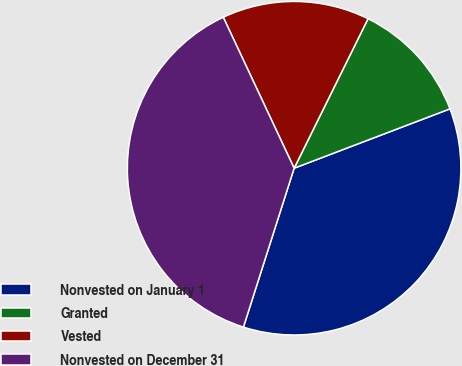Convert chart. <chart><loc_0><loc_0><loc_500><loc_500><pie_chart><fcel>Nonvested on January 1<fcel>Granted<fcel>Vested<fcel>Nonvested on December 31<nl><fcel>35.71%<fcel>11.9%<fcel>14.29%<fcel>38.1%<nl></chart> 